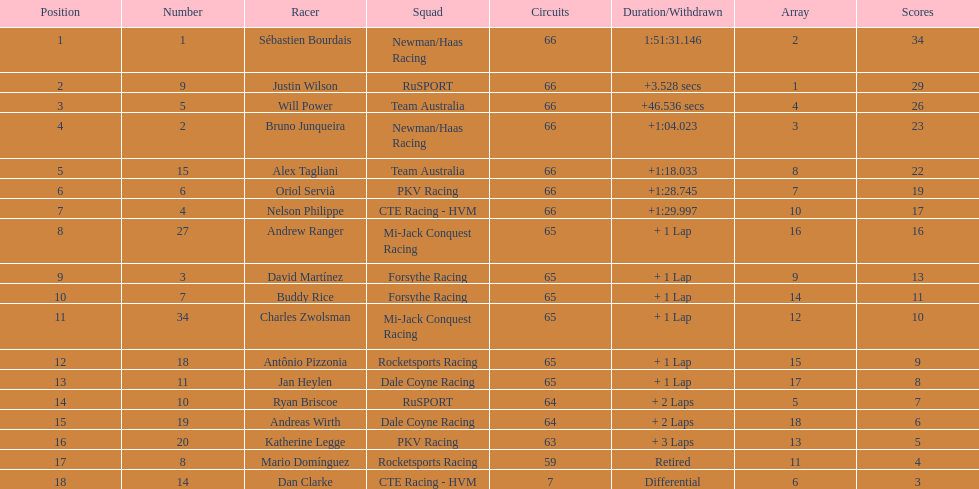What is the number of laps dan clarke completed? 7. 